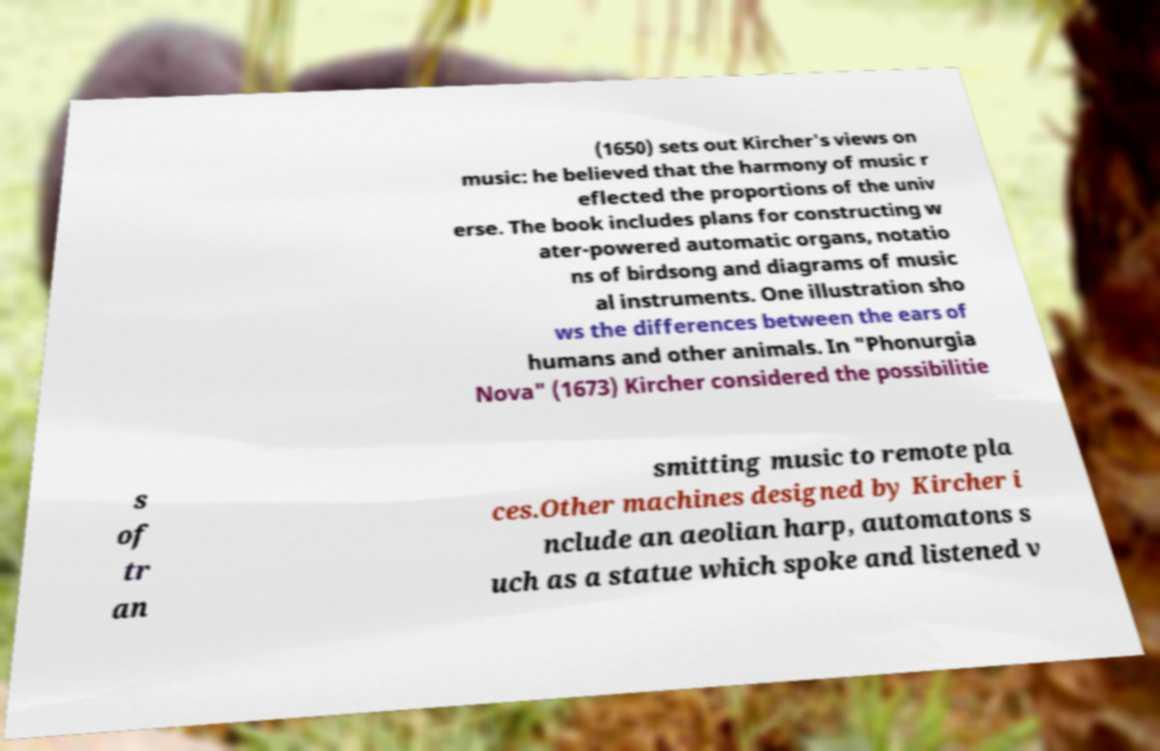Can you accurately transcribe the text from the provided image for me? (1650) sets out Kircher's views on music: he believed that the harmony of music r eflected the proportions of the univ erse. The book includes plans for constructing w ater-powered automatic organs, notatio ns of birdsong and diagrams of music al instruments. One illustration sho ws the differences between the ears of humans and other animals. In "Phonurgia Nova" (1673) Kircher considered the possibilitie s of tr an smitting music to remote pla ces.Other machines designed by Kircher i nclude an aeolian harp, automatons s uch as a statue which spoke and listened v 